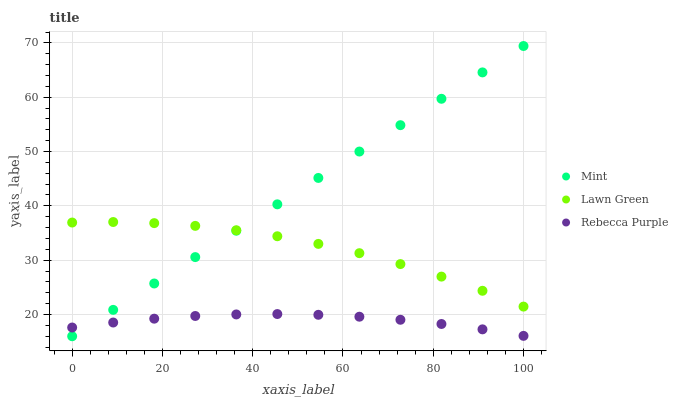Does Rebecca Purple have the minimum area under the curve?
Answer yes or no. Yes. Does Mint have the maximum area under the curve?
Answer yes or no. Yes. Does Mint have the minimum area under the curve?
Answer yes or no. No. Does Rebecca Purple have the maximum area under the curve?
Answer yes or no. No. Is Mint the smoothest?
Answer yes or no. Yes. Is Lawn Green the roughest?
Answer yes or no. Yes. Is Rebecca Purple the smoothest?
Answer yes or no. No. Is Rebecca Purple the roughest?
Answer yes or no. No. Does Mint have the lowest value?
Answer yes or no. Yes. Does Rebecca Purple have the lowest value?
Answer yes or no. No. Does Mint have the highest value?
Answer yes or no. Yes. Does Rebecca Purple have the highest value?
Answer yes or no. No. Is Rebecca Purple less than Lawn Green?
Answer yes or no. Yes. Is Lawn Green greater than Rebecca Purple?
Answer yes or no. Yes. Does Mint intersect Lawn Green?
Answer yes or no. Yes. Is Mint less than Lawn Green?
Answer yes or no. No. Is Mint greater than Lawn Green?
Answer yes or no. No. Does Rebecca Purple intersect Lawn Green?
Answer yes or no. No. 